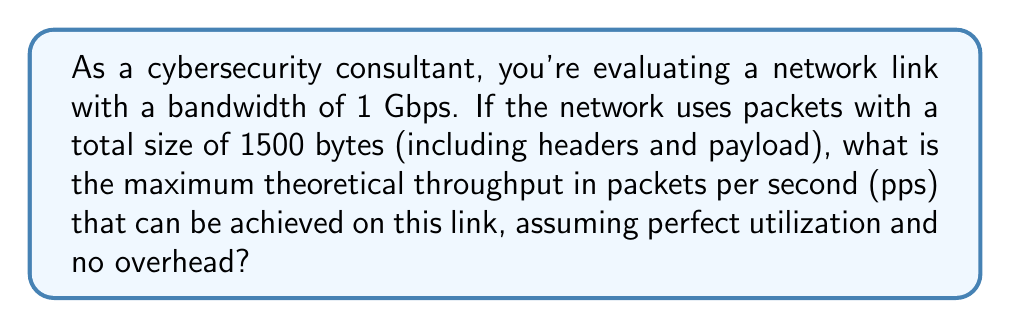Could you help me with this problem? To solve this problem, we need to follow these steps:

1. Convert the bandwidth from bits per second to bytes per second:
   $$ 1 \text{ Gbps} = 1,000,000,000 \text{ bps} = \frac{1,000,000,000}{8} \text{ Bps} = 125,000,000 \text{ Bps} $$

2. Calculate how many packets can be transmitted in one second:
   Let $x$ be the number of packets per second.
   $$ x \cdot 1500 \text{ bytes} = 125,000,000 \text{ Bps} $$

3. Solve for $x$:
   $$ x = \frac{125,000,000}{1500} = 83,333.33 \text{ pps} $$

4. Since we can't transmit a fraction of a packet, we round down to the nearest whole number:
   $$ x = 83,333 \text{ pps} $$

This calculation assumes perfect utilization of the network link with no additional overhead or inter-packet gaps. In real-world scenarios, the actual throughput would be lower due to various factors such as protocol overhead, network congestion, and processing delays.
Answer: The maximum theoretical throughput is 83,333 packets per second. 